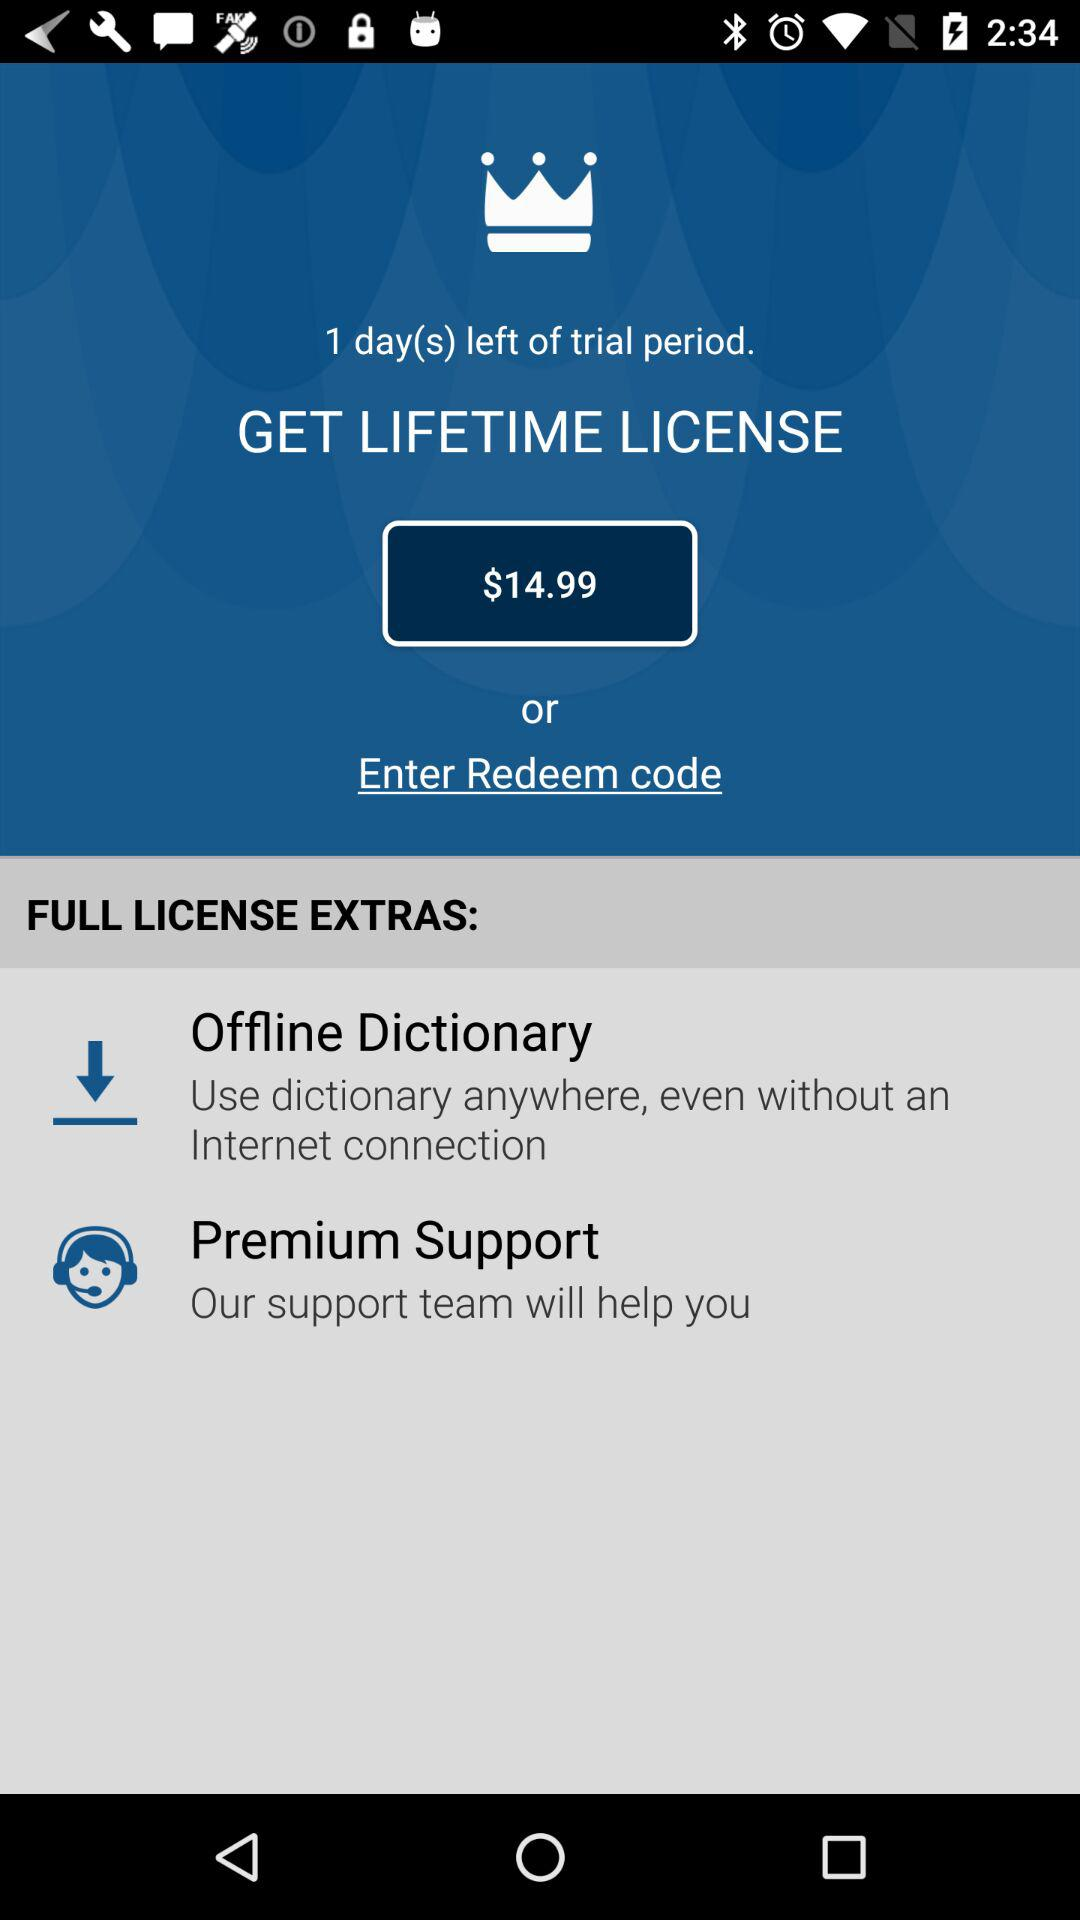How many days are left in the trial period? There is 1 day left in the trial period. 